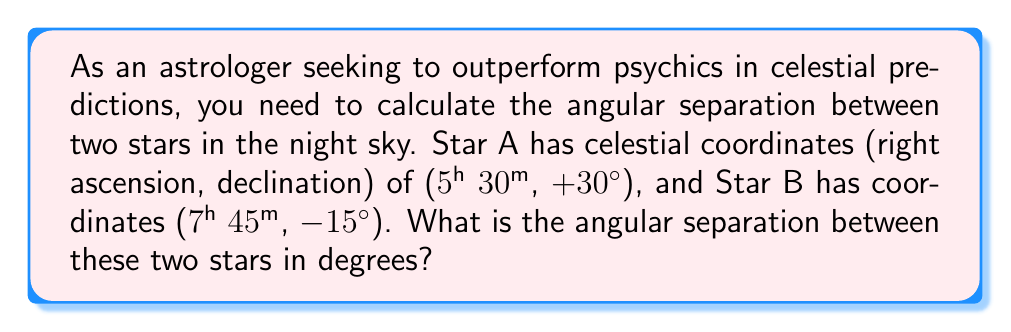Could you help me with this problem? To calculate the angular separation between two stars, we can use the spherical law of cosines. Let's follow these steps:

1. Convert the right ascension (RA) from hours to degrees:
   For Star A: $RA_A = 5h 30m = 5.5h = 5.5 \times 15° = 82.5°$
   For Star B: $RA_B = 7h 45m = 7.75h = 7.75 \times 15° = 116.25°$

2. Convert declination (Dec) to radians:
   $Dec_A = 30° = \frac{30\pi}{180} \approx 0.5236$ rad
   $Dec_B = -15° = \frac{-15\pi}{180} \approx -0.2618$ rad

3. Calculate the difference in right ascension:
   $\Delta RA = |RA_A - RA_B| = |82.5° - 116.25°| = 33.75°$
   Convert to radians: $\Delta RA = \frac{33.75\pi}{180} \approx 0.5890$ rad

4. Apply the spherical law of cosines:
   $$\cos(\theta) = \sin(Dec_A)\sin(Dec_B) + \cos(Dec_A)\cos(Dec_B)\cos(\Delta RA)$$

   Where $\theta$ is the angular separation we're looking for.

5. Substitute the values:
   $$\cos(\theta) = \sin(0.5236)\sin(-0.2618) + \cos(0.5236)\cos(-0.2618)\cos(0.5890)$$

6. Evaluate:
   $$\cos(\theta) \approx -0.1305 \times (-0.2588) + 0.8660 \times 0.9659 \times 0.8277 \approx 0.7112$$

7. Take the inverse cosine (arccos) of both sides:
   $$\theta = \arccos(0.7112) \approx 0.7857 \text{ rad}$$

8. Convert back to degrees:
   $$\theta = 0.7857 \times \frac{180}{\pi} \approx 45.02°$$
Answer: The angular separation between the two stars is approximately 45.02°. 